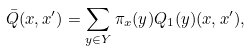<formula> <loc_0><loc_0><loc_500><loc_500>\bar { Q } ( x , x ^ { \prime } ) = \sum _ { y \in Y } \pi _ { x } ( y ) Q _ { 1 } ( y ) ( x , x ^ { \prime } ) ,</formula> 